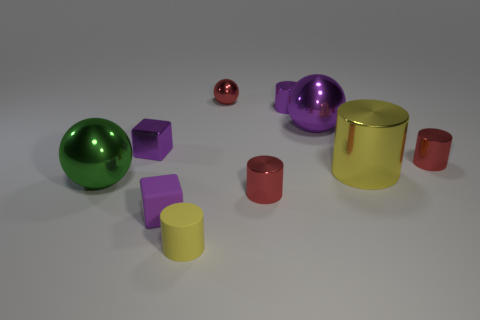Subtract all purple cylinders. How many cylinders are left? 4 Subtract all small purple shiny cylinders. How many cylinders are left? 4 Subtract all brown cylinders. Subtract all purple spheres. How many cylinders are left? 5 Subtract all balls. How many objects are left? 7 Add 2 yellow cylinders. How many yellow cylinders are left? 4 Add 4 small cyan balls. How many small cyan balls exist? 4 Subtract 0 yellow cubes. How many objects are left? 10 Subtract all large green spheres. Subtract all small shiny blocks. How many objects are left? 8 